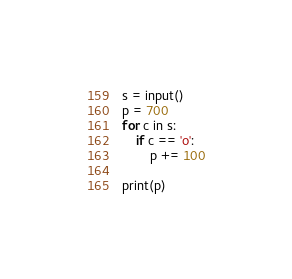<code> <loc_0><loc_0><loc_500><loc_500><_Python_>s = input()
p = 700
for c in s:
    if c == 'o':
        p += 100

print(p)</code> 